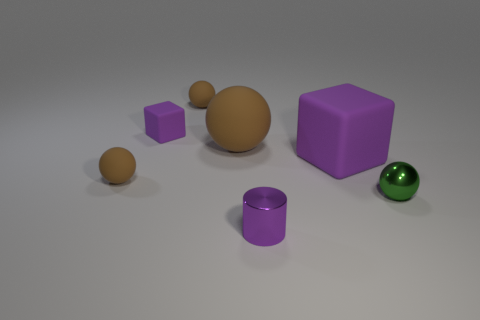Does the green thing have the same material as the cylinder?
Your answer should be compact. Yes. How many objects are small rubber balls left of the tiny purple metallic thing or big matte objects that are to the right of the cylinder?
Provide a short and direct response. 3. What color is the other matte object that is the same shape as the tiny purple rubber object?
Make the answer very short. Purple. What number of tiny rubber blocks are the same color as the big matte cube?
Offer a terse response. 1. Does the small cube have the same color as the small cylinder?
Keep it short and to the point. Yes. How many things are cubes that are to the left of the small purple cylinder or small cyan blocks?
Make the answer very short. 1. There is a block that is left of the tiny object that is behind the small purple object left of the tiny purple cylinder; what color is it?
Your response must be concise. Purple. The large ball that is made of the same material as the large purple cube is what color?
Provide a succinct answer. Brown. How many green things have the same material as the large purple thing?
Ensure brevity in your answer.  0. Is the size of the metal object left of the green object the same as the large purple object?
Your answer should be very brief. No. 